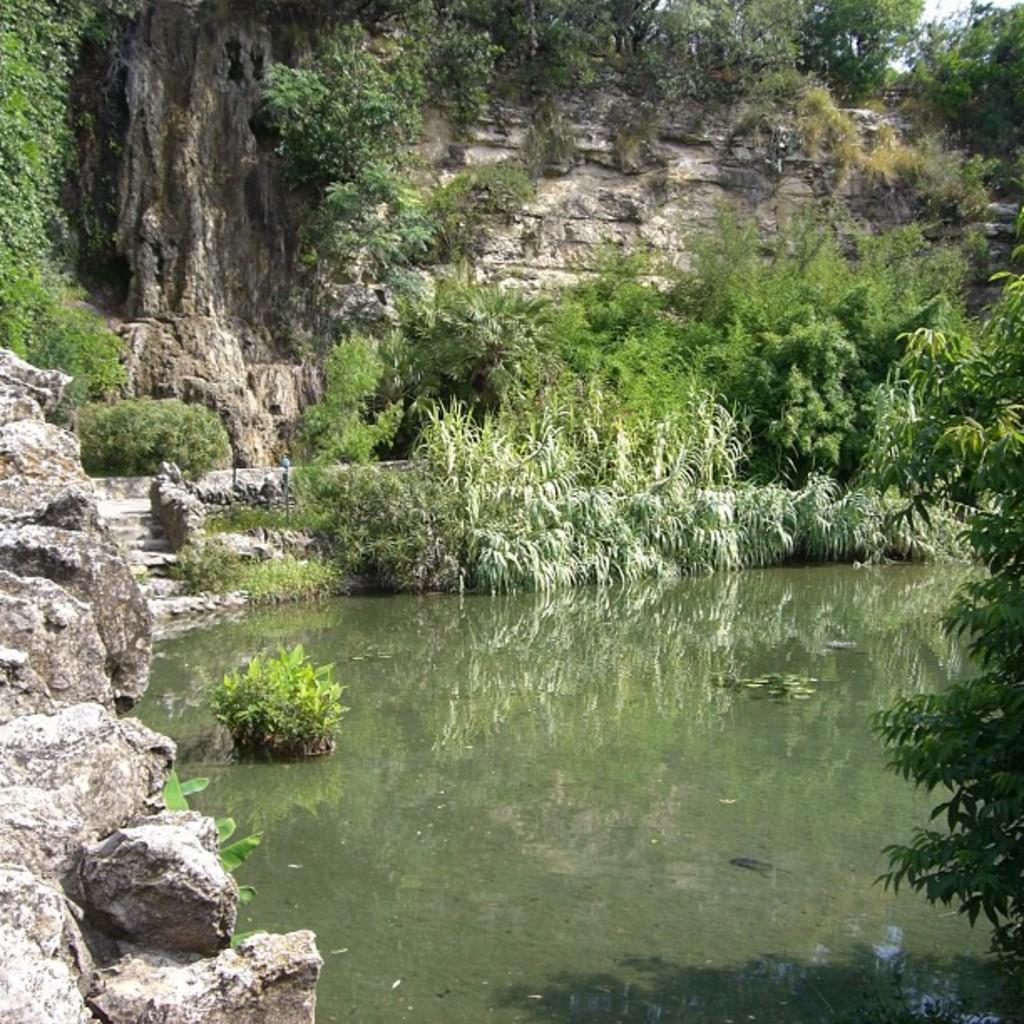How would you summarize this image in a sentence or two? In this image we can see lake, bushes, shrubs, stones, trees, rocks and sky. 